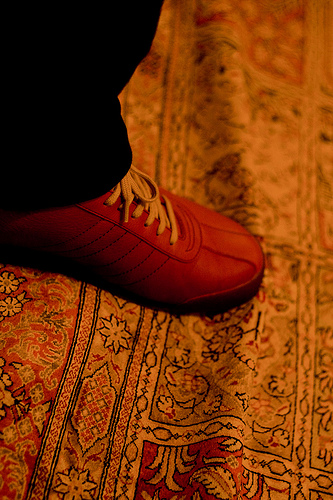<image>
Is there a shoe above the rug? No. The shoe is not positioned above the rug. The vertical arrangement shows a different relationship. 